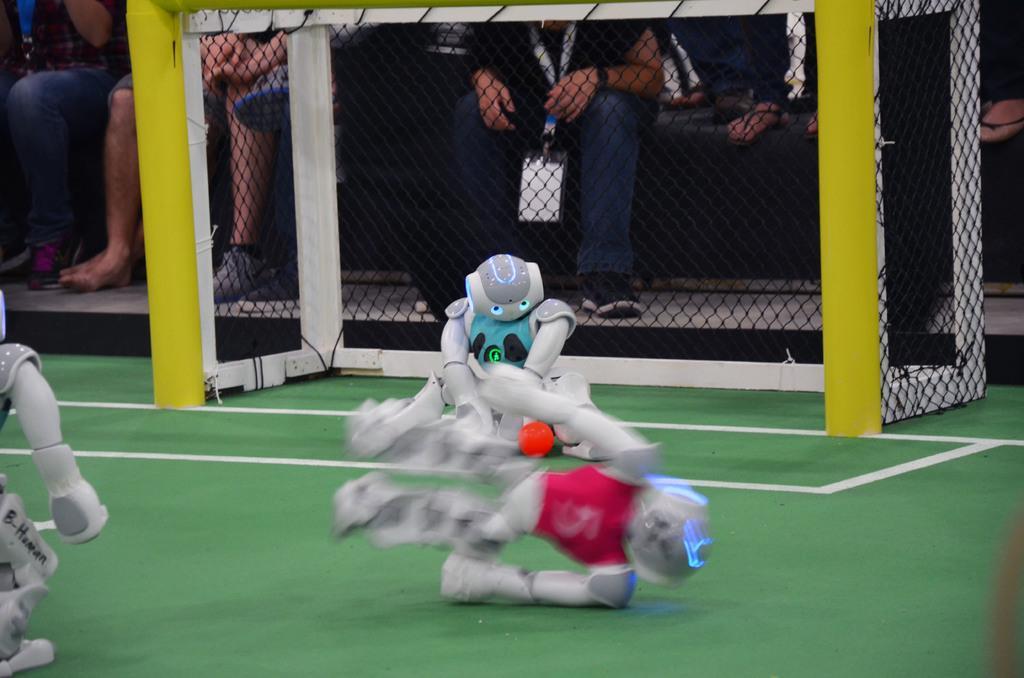In one or two sentences, can you explain what this image depicts? On the left side, there is a white color robot on a green colored court. In the middle of this image, there are two robots playing football on the green colored court. In the background, there is a net and there are persons in different color dresses sitting. 